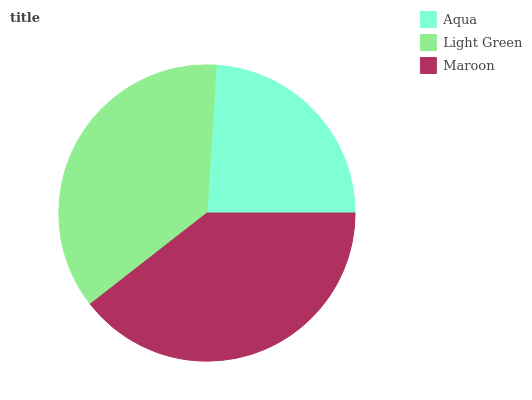Is Aqua the minimum?
Answer yes or no. Yes. Is Maroon the maximum?
Answer yes or no. Yes. Is Light Green the minimum?
Answer yes or no. No. Is Light Green the maximum?
Answer yes or no. No. Is Light Green greater than Aqua?
Answer yes or no. Yes. Is Aqua less than Light Green?
Answer yes or no. Yes. Is Aqua greater than Light Green?
Answer yes or no. No. Is Light Green less than Aqua?
Answer yes or no. No. Is Light Green the high median?
Answer yes or no. Yes. Is Light Green the low median?
Answer yes or no. Yes. Is Maroon the high median?
Answer yes or no. No. Is Aqua the low median?
Answer yes or no. No. 